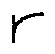<formula> <loc_0><loc_0><loc_500><loc_500>r</formula> 